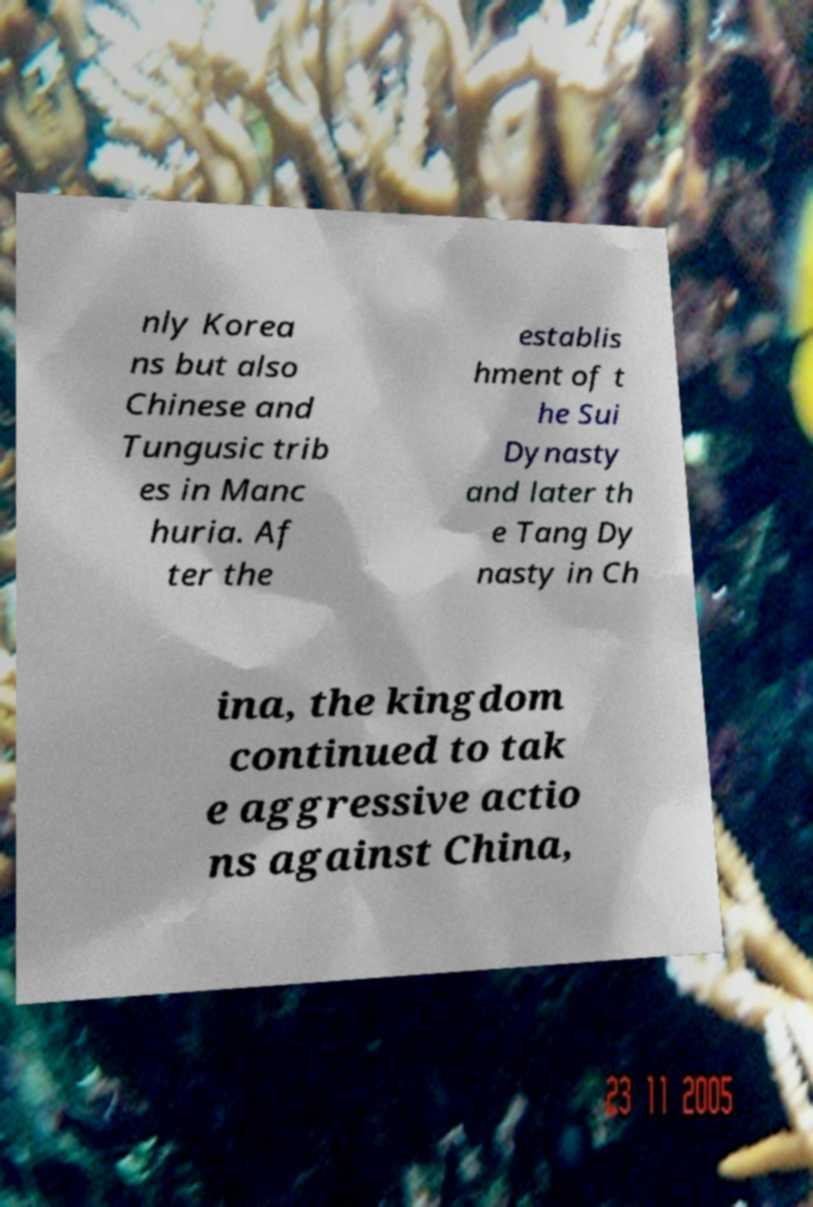Could you extract and type out the text from this image? nly Korea ns but also Chinese and Tungusic trib es in Manc huria. Af ter the establis hment of t he Sui Dynasty and later th e Tang Dy nasty in Ch ina, the kingdom continued to tak e aggressive actio ns against China, 